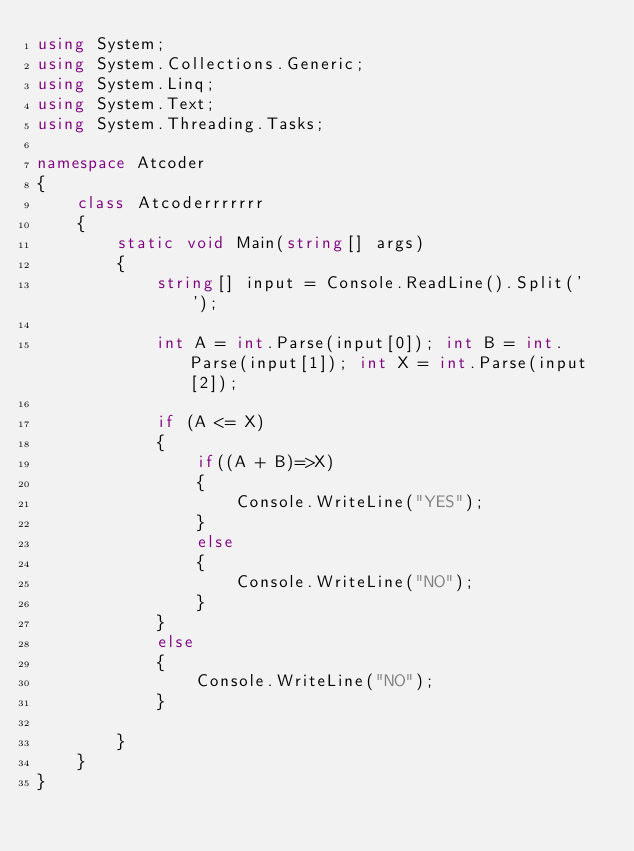Convert code to text. <code><loc_0><loc_0><loc_500><loc_500><_C#_>using System;
using System.Collections.Generic;
using System.Linq;
using System.Text;
using System.Threading.Tasks;

namespace Atcoder
{
    class Atcoderrrrrrr
    {
        static void Main(string[] args)
        {
            string[] input = Console.ReadLine().Split(' ');

            int A = int.Parse(input[0]); int B = int.Parse(input[1]); int X = int.Parse(input[2]);

            if (A <= X)
            {
                if((A + B)=>X)
                {
                    Console.WriteLine("YES");
                }
                else
                {
                    Console.WriteLine("NO");
                }
            }
            else
            {
                Console.WriteLine("NO");
            }

        }
    }
}
</code> 